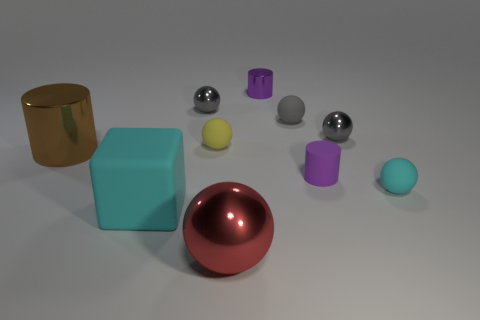Subtract all gray spheres. How many were subtracted if there are1gray spheres left? 2 Subtract all red cylinders. How many gray balls are left? 3 Subtract all red spheres. How many spheres are left? 5 Subtract all large red metallic balls. How many balls are left? 5 Subtract all green spheres. Subtract all cyan blocks. How many spheres are left? 6 Subtract all cylinders. How many objects are left? 7 Add 9 purple metallic cylinders. How many purple metallic cylinders exist? 10 Subtract 2 purple cylinders. How many objects are left? 8 Subtract all tiny spheres. Subtract all yellow balls. How many objects are left? 4 Add 6 large cubes. How many large cubes are left? 7 